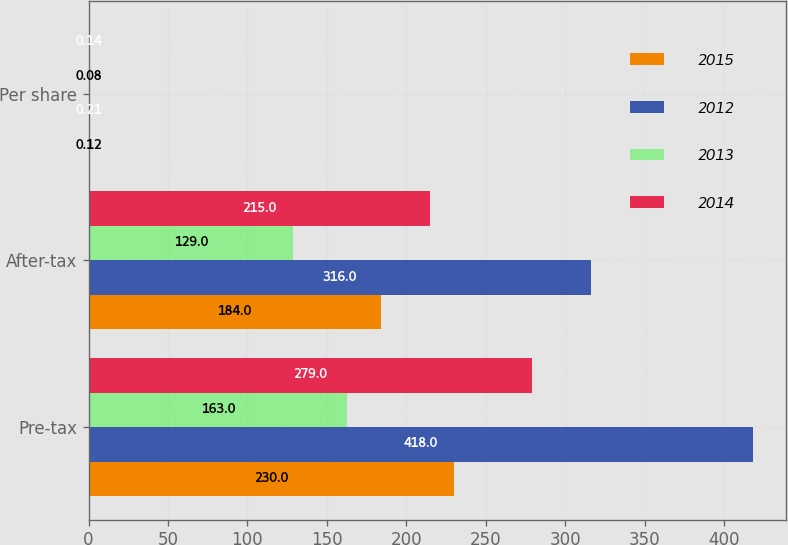Convert chart to OTSL. <chart><loc_0><loc_0><loc_500><loc_500><stacked_bar_chart><ecel><fcel>Pre-tax<fcel>After-tax<fcel>Per share<nl><fcel>2015<fcel>230<fcel>184<fcel>0.12<nl><fcel>2012<fcel>418<fcel>316<fcel>0.21<nl><fcel>2013<fcel>163<fcel>129<fcel>0.08<nl><fcel>2014<fcel>279<fcel>215<fcel>0.14<nl></chart> 